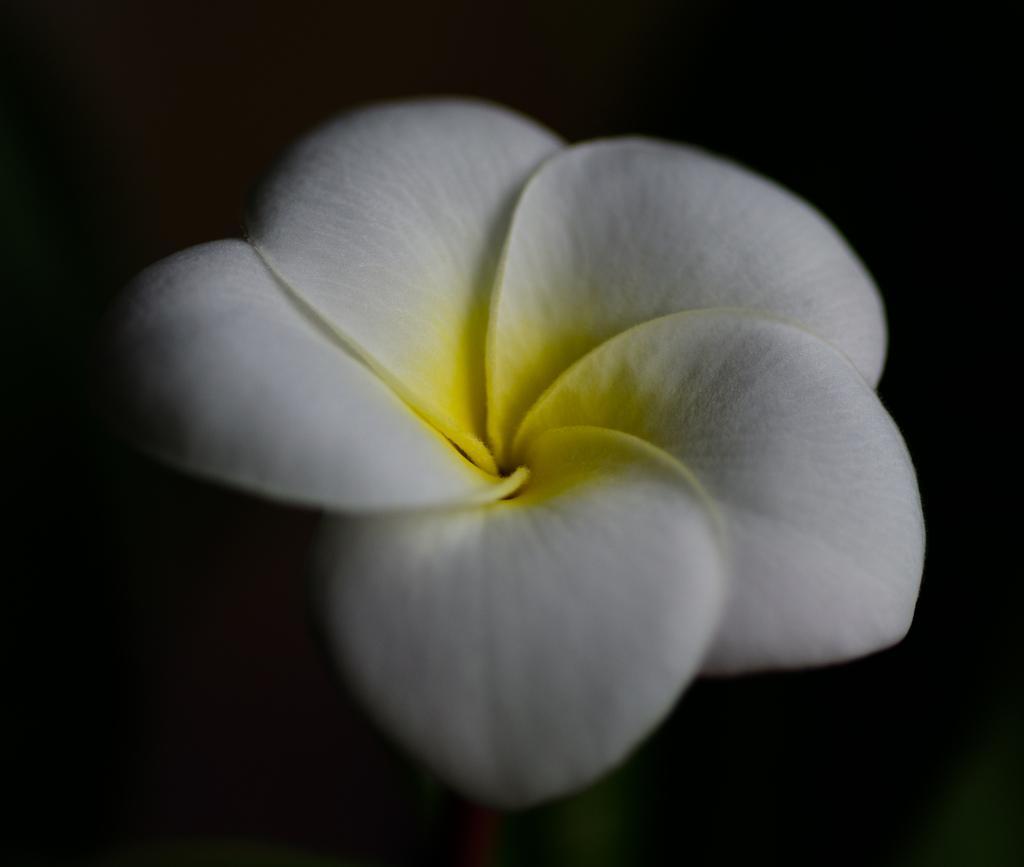Please provide a concise description of this image. This is a zoomed in picture. In the center there is a white color flower. The background of the image is very dark. 